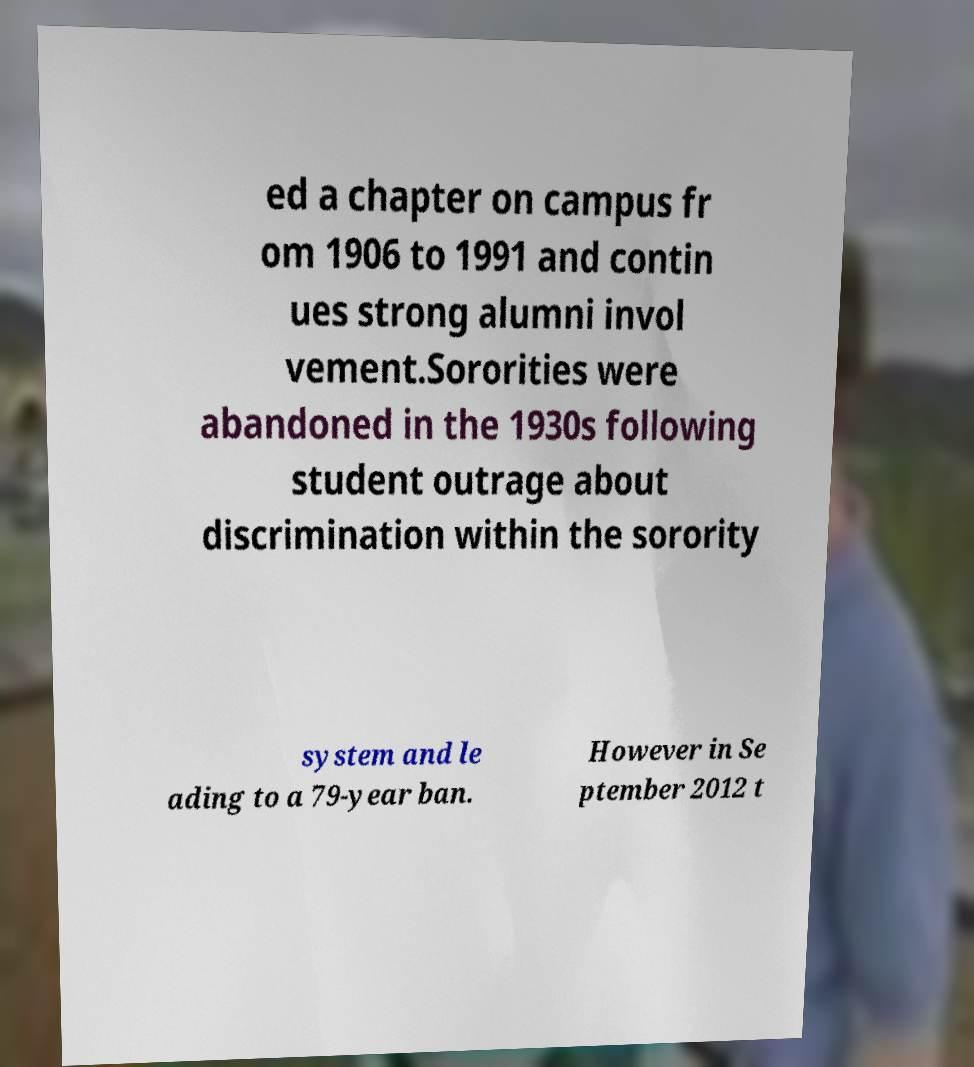For documentation purposes, I need the text within this image transcribed. Could you provide that? ed a chapter on campus fr om 1906 to 1991 and contin ues strong alumni invol vement.Sororities were abandoned in the 1930s following student outrage about discrimination within the sorority system and le ading to a 79-year ban. However in Se ptember 2012 t 